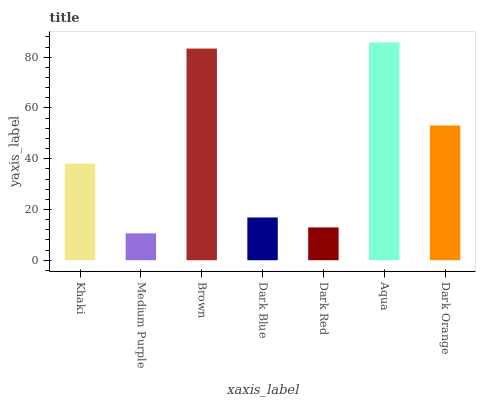Is Medium Purple the minimum?
Answer yes or no. Yes. Is Aqua the maximum?
Answer yes or no. Yes. Is Brown the minimum?
Answer yes or no. No. Is Brown the maximum?
Answer yes or no. No. Is Brown greater than Medium Purple?
Answer yes or no. Yes. Is Medium Purple less than Brown?
Answer yes or no. Yes. Is Medium Purple greater than Brown?
Answer yes or no. No. Is Brown less than Medium Purple?
Answer yes or no. No. Is Khaki the high median?
Answer yes or no. Yes. Is Khaki the low median?
Answer yes or no. Yes. Is Dark Orange the high median?
Answer yes or no. No. Is Dark Orange the low median?
Answer yes or no. No. 